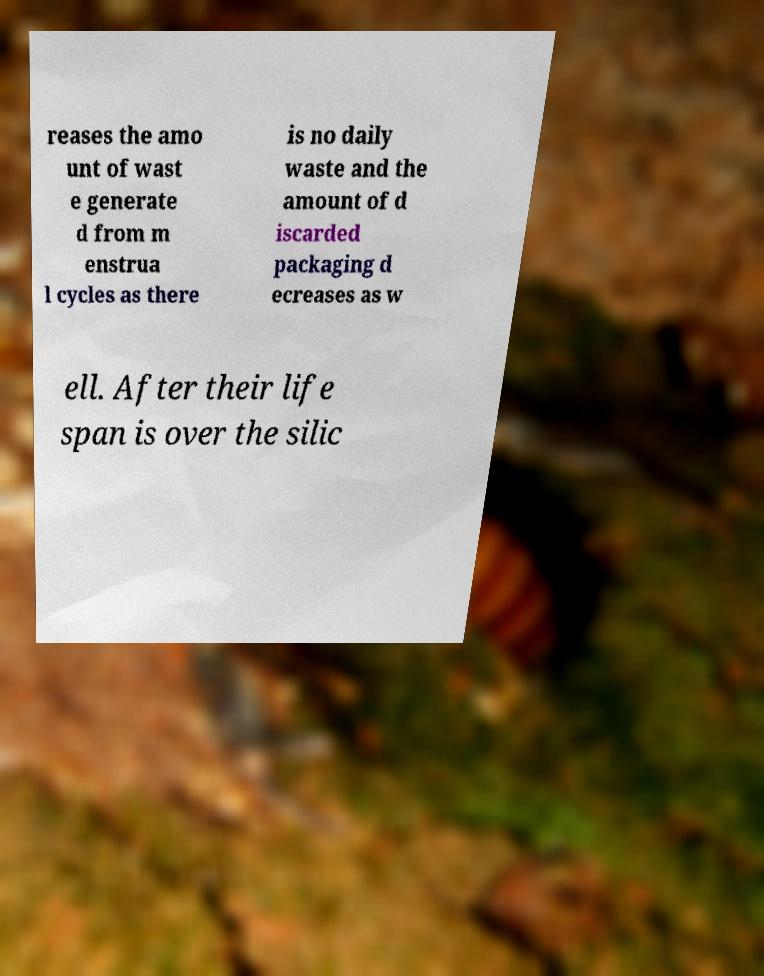Could you assist in decoding the text presented in this image and type it out clearly? reases the amo unt of wast e generate d from m enstrua l cycles as there is no daily waste and the amount of d iscarded packaging d ecreases as w ell. After their life span is over the silic 